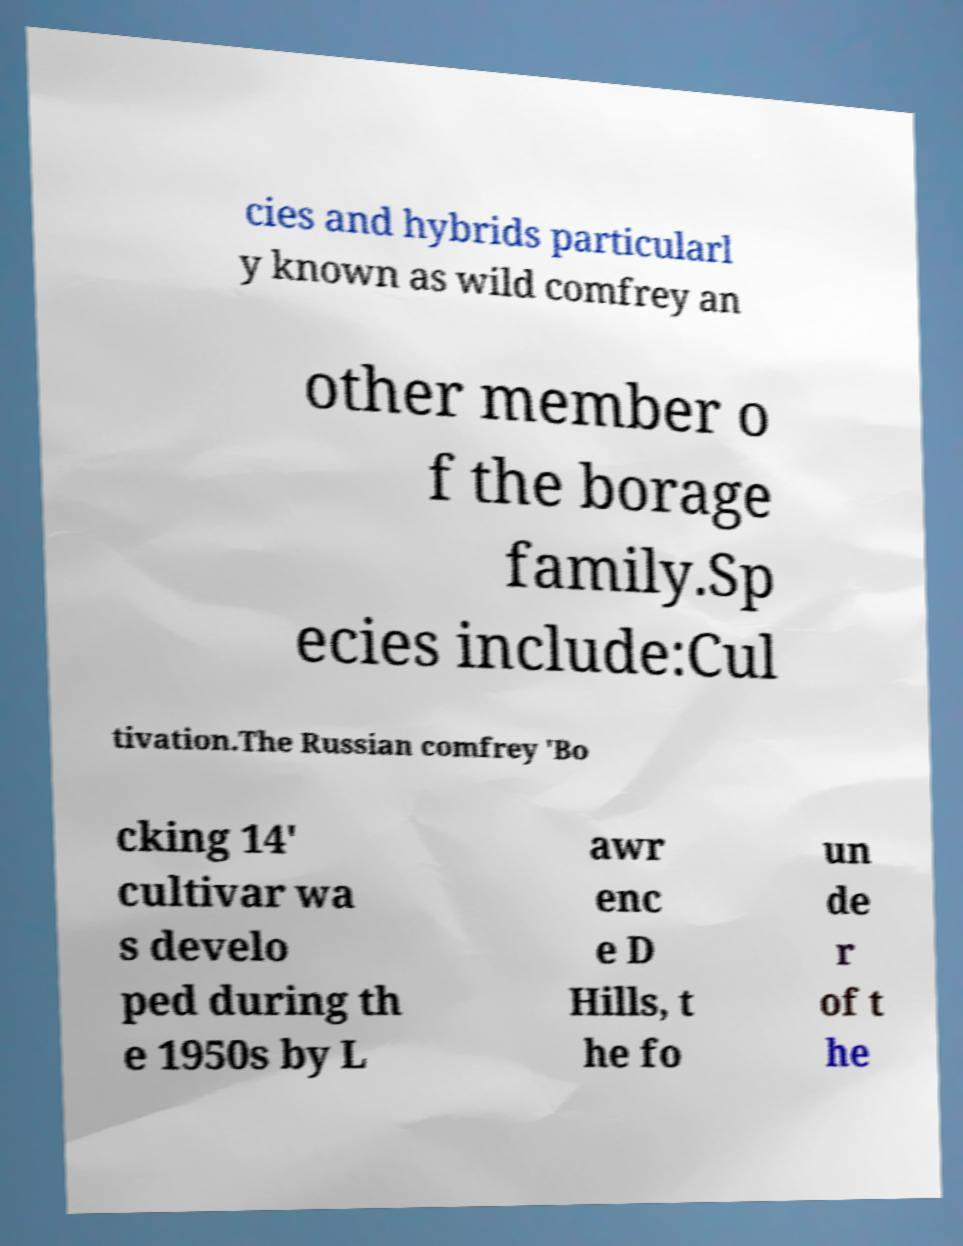Could you extract and type out the text from this image? cies and hybrids particularl y known as wild comfrey an other member o f the borage family.Sp ecies include:Cul tivation.The Russian comfrey 'Bo cking 14' cultivar wa s develo ped during th e 1950s by L awr enc e D Hills, t he fo un de r of t he 